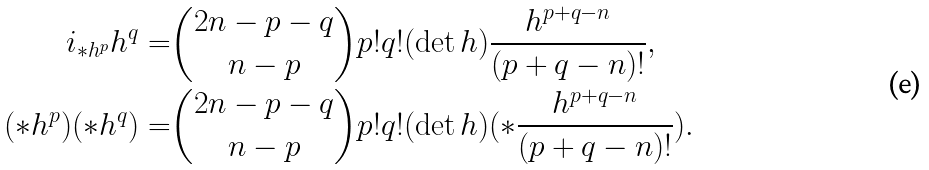Convert formula to latex. <formula><loc_0><loc_0><loc_500><loc_500>i _ { * h ^ { p } } h ^ { q } = & \binom { 2 n - p - q } { n - p } p ! q ! ( \det h ) \frac { h ^ { p + q - n } } { ( p + q - n ) ! } , \\ ( * h ^ { p } ) ( * h ^ { q } ) = & \binom { 2 n - p - q } { n - p } p ! q ! ( \det h ) ( * \frac { h ^ { p + q - n } } { ( p + q - n ) ! } ) .</formula> 